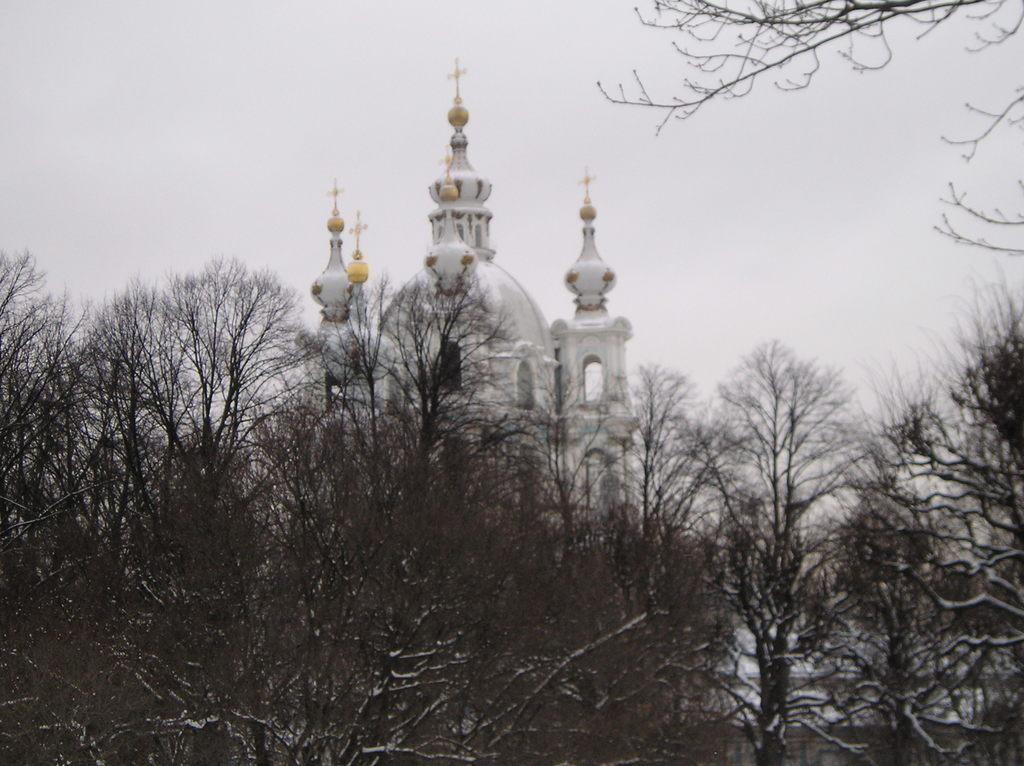What type of vegetation can be seen in the image? There are trees in the image. What is located behind the trees in the image? There is a building behind the trees in the image. What part of the natural environment is visible in the image? The sky is visible in the image. What type of education can be seen in the middle of the image? There is no reference to education in the image; it features trees, a building, and the sky. 